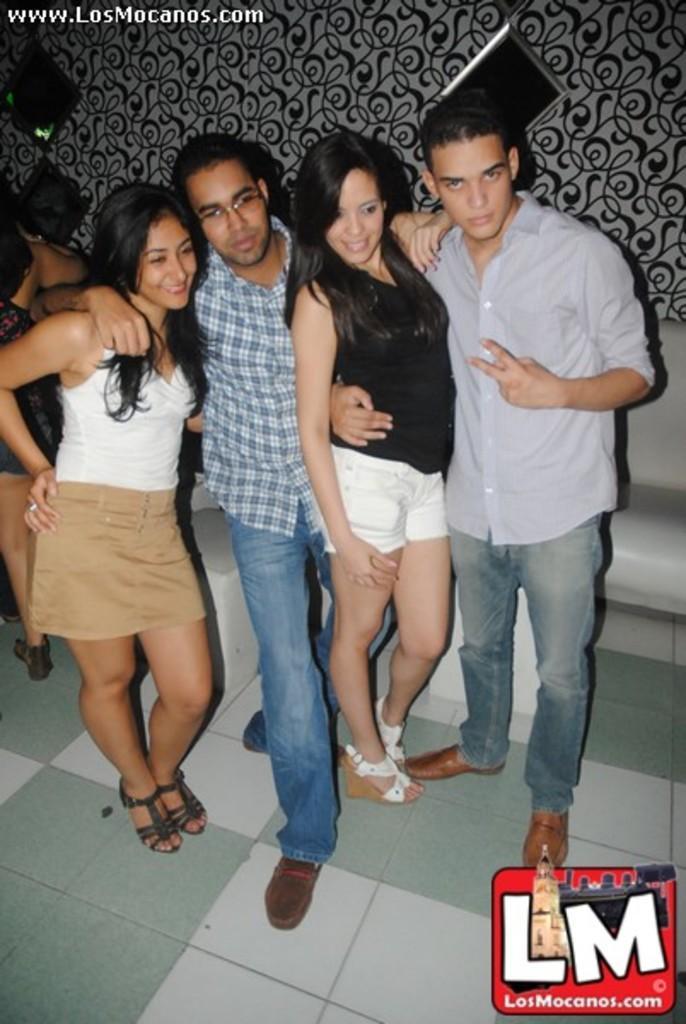Can you describe this image briefly? In this picture i can see group of people are standing on the floor. Among them men are wearing shirts, pants and shoes. In the background i can see a wall and bottom right corner side i can see logo. 